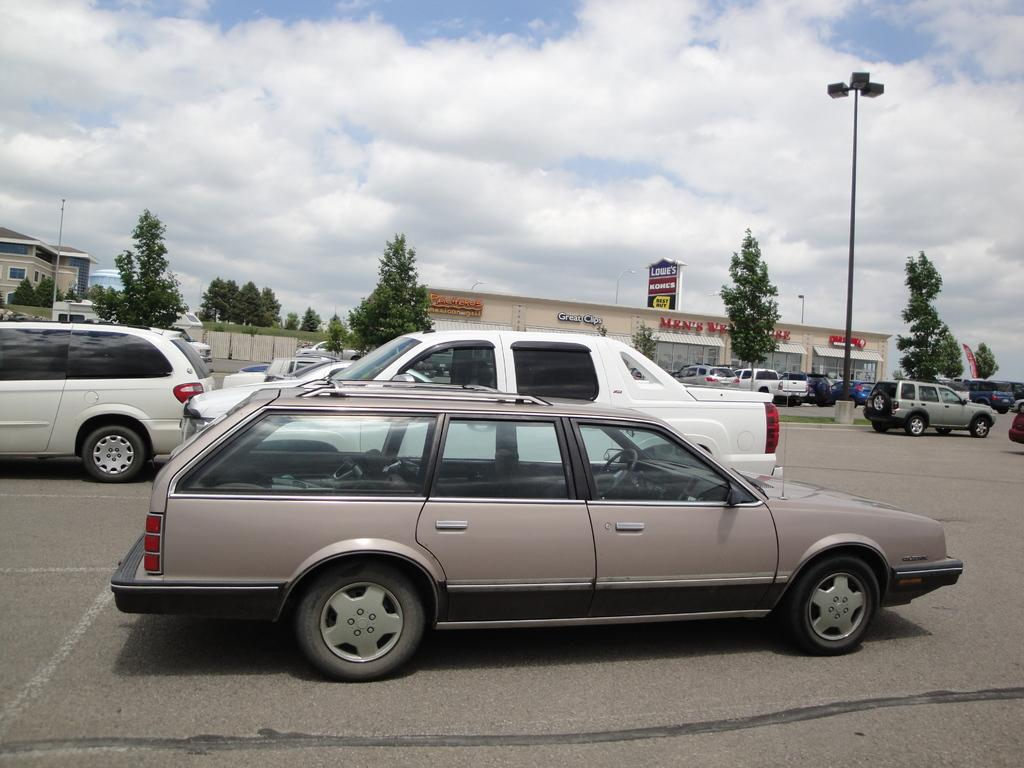What is the main subject in the center of the image? There is a car in the center of the image. Where is the car located? The car is on the road. What can be seen in the background of the image? There are cars, a light pole, trees, buildings, and the sky in the background. What is the condition of the sky in the image? The sky has clouds in the image. What is the limit of the car's neck in the image? There is no mention of a car's neck in the image, as cars do not have necks. 